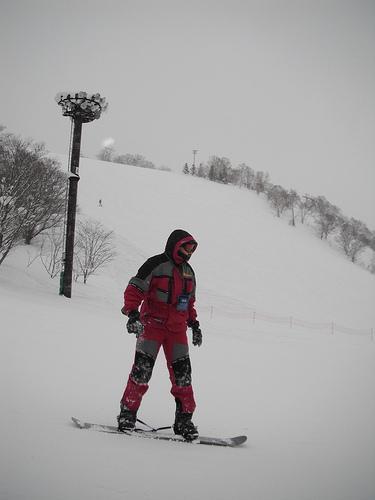How many people are there?
Give a very brief answer. 1. 